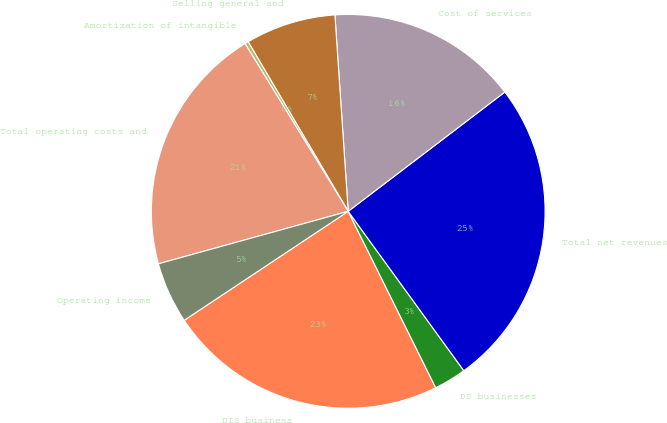Convert chart. <chart><loc_0><loc_0><loc_500><loc_500><pie_chart><fcel>DIS business<fcel>DS businesses<fcel>Total net revenues<fcel>Cost of services<fcel>Selling general and<fcel>Amortization of intangible<fcel>Total operating costs and<fcel>Operating income<nl><fcel>23.0%<fcel>2.66%<fcel>25.37%<fcel>15.72%<fcel>7.41%<fcel>0.29%<fcel>20.52%<fcel>5.04%<nl></chart> 